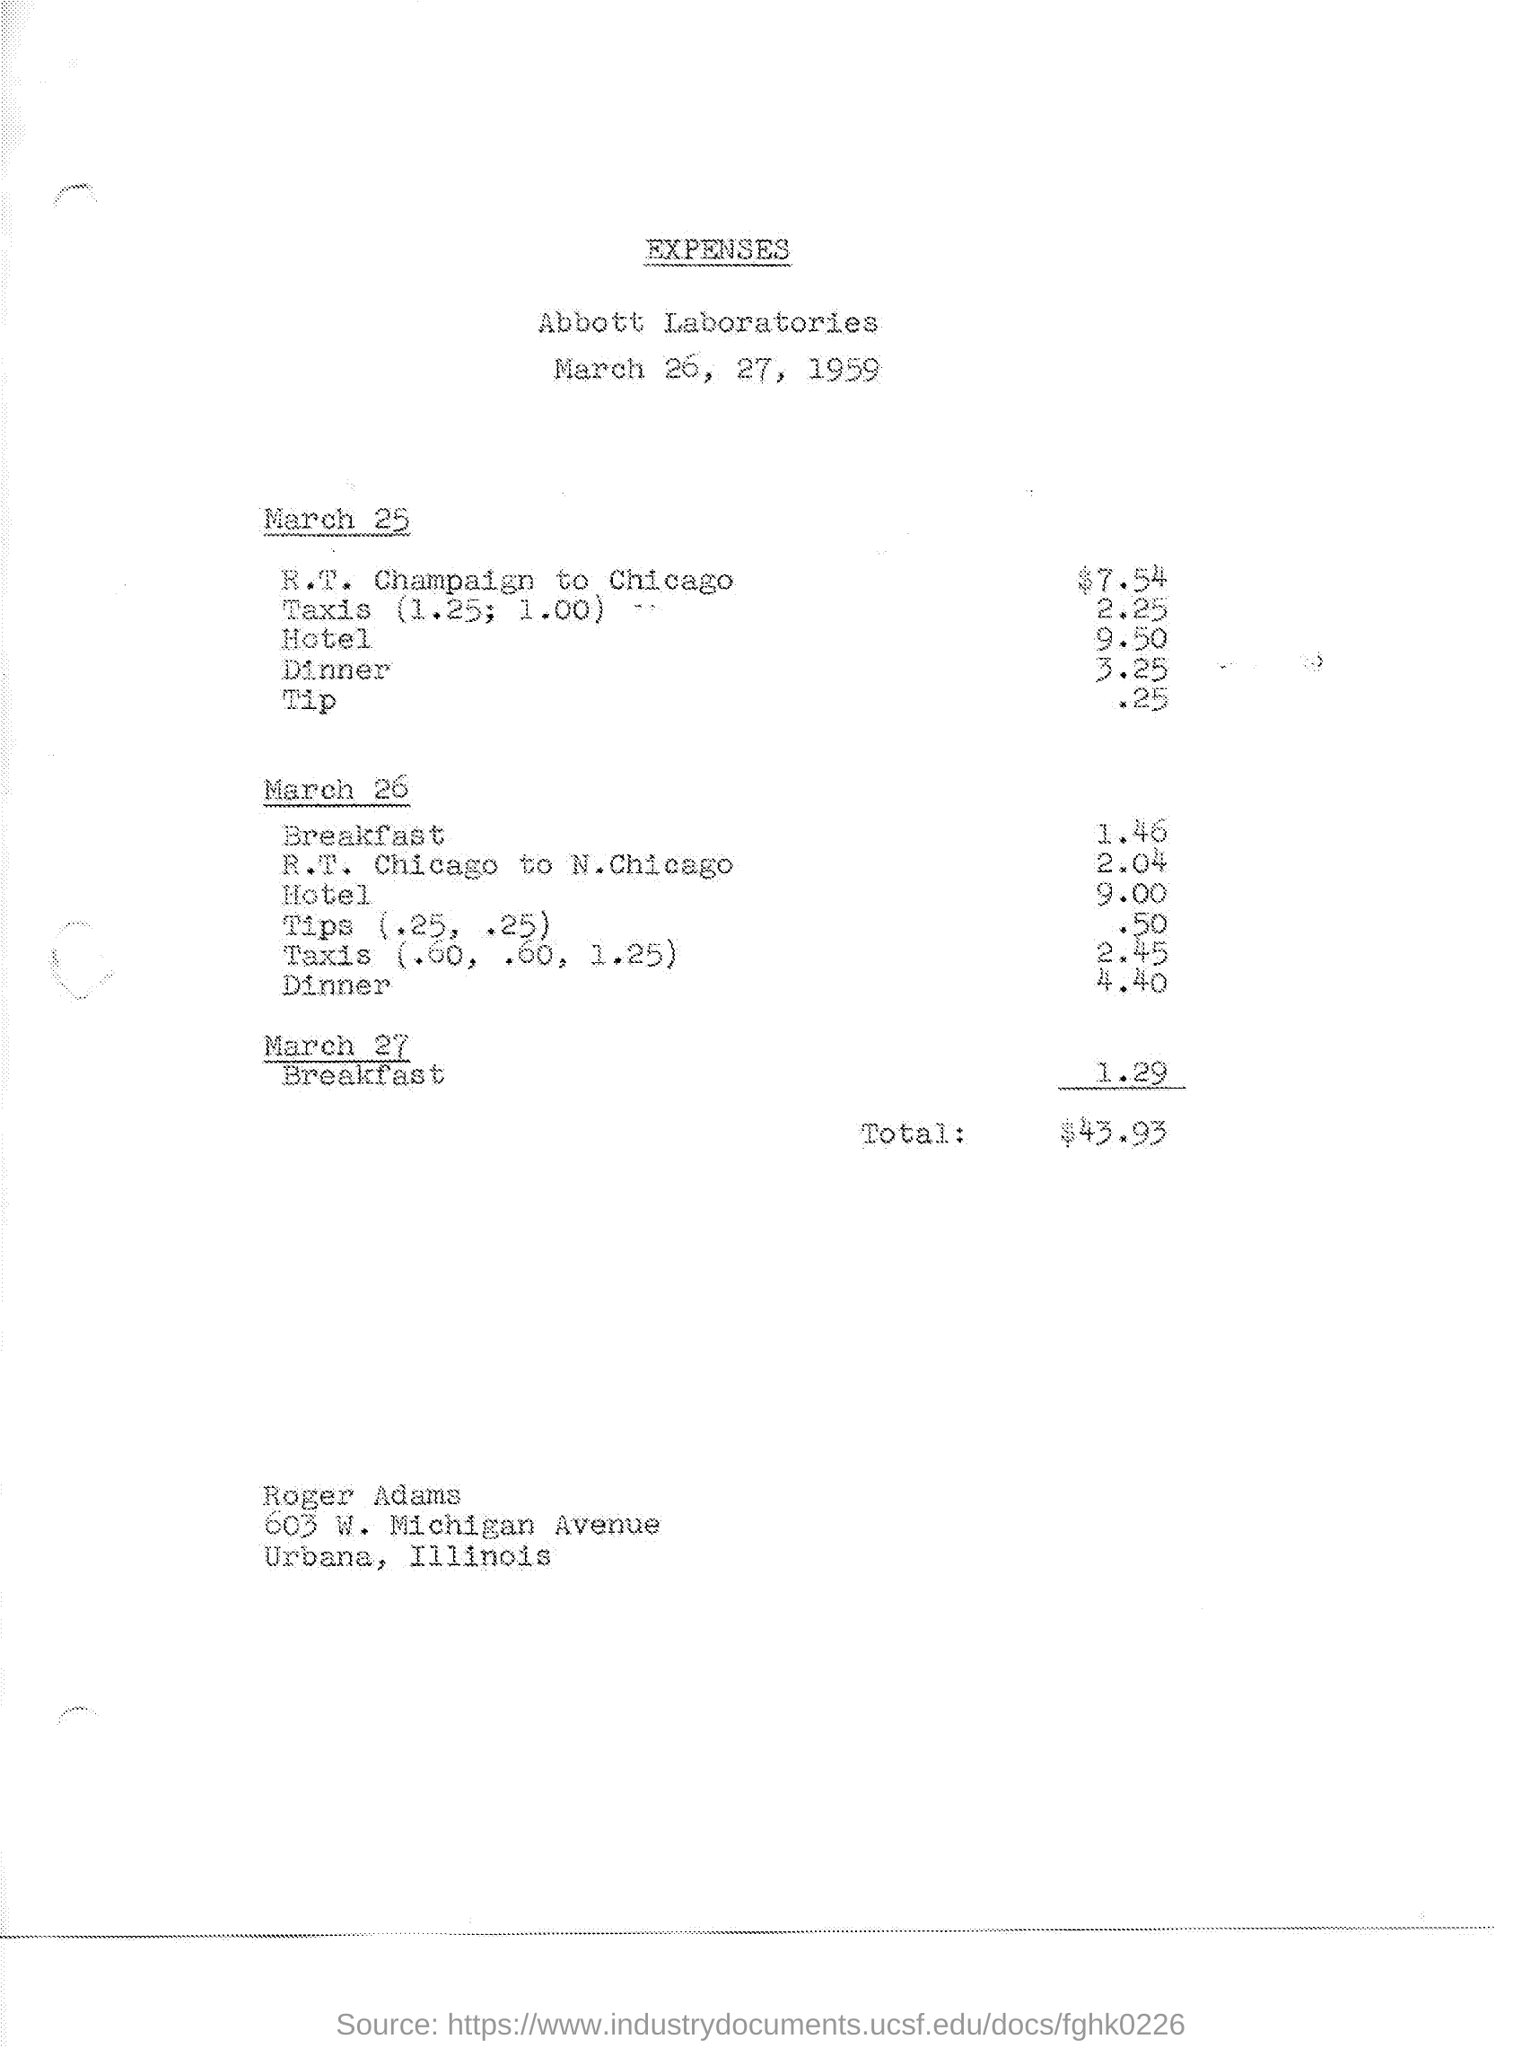Point out several critical features in this image. On March 27, the expenses for breakfast were 1.29. On March 25, the expenses for taxis were 2.25. On March 25, the expenses for traveling from R.T. Champaign to Chicago were $7.54. On March 26, the expenses for dinner were 4.40. I request to know the expenses for traveling from R.T. Champaign to N.Chicago on March 26th, 2.04. 